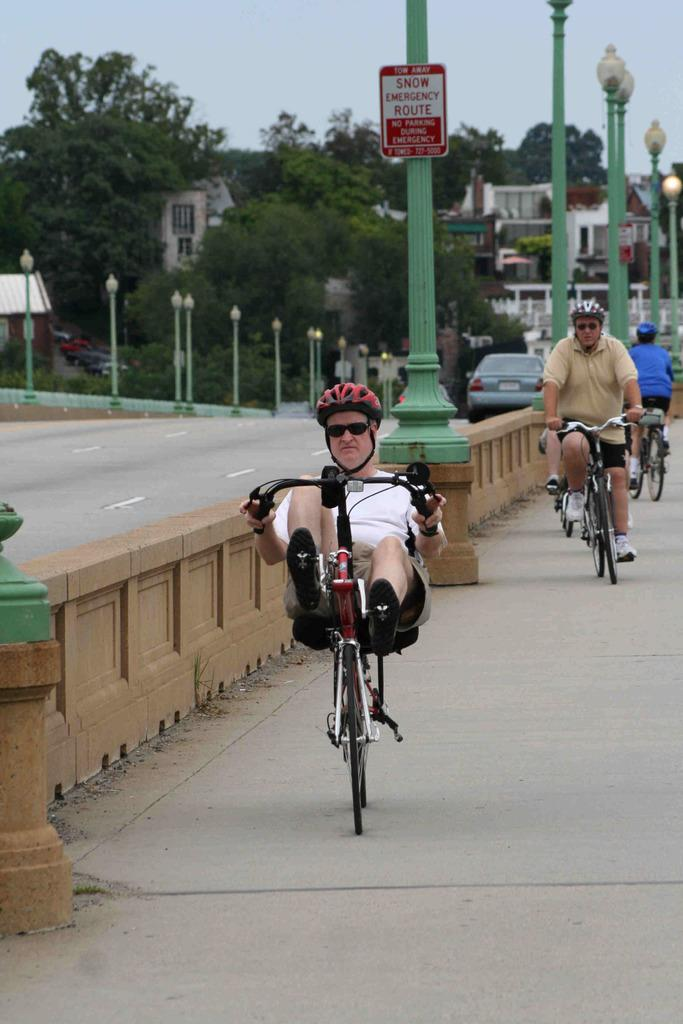What are the persons in the image doing? The persons in the image are riding bicycles. What safety precaution are the persons taking while riding bicycles? The persons are wearing helmets. What can be seen in the background of the image? There are trees, buildings, poles, and vehicles in the background of the image. What part of the natural environment is visible in the image? The sky is visible in the background of the image. What type of silk is being woven by the persons riding bicycles in the image? There is no silk or weaving activity present in the image; the persons are riding bicycles. What type of quartz can be seen in the image? There is no quartz present in the image. 